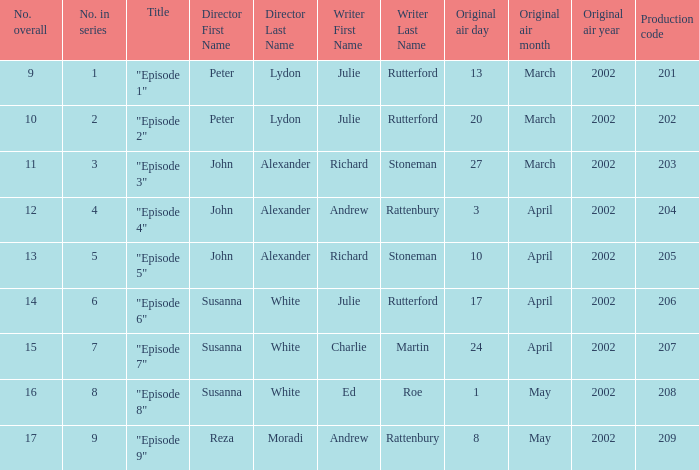Can you parse all the data within this table? {'header': ['No. overall', 'No. in series', 'Title', 'Director First Name', 'Director Last Name', 'Writer First Name', 'Writer Last Name', 'Original air day', 'Original air month', 'Original air year', 'Production code'], 'rows': [['9', '1', '"Episode 1"', 'Peter', 'Lydon', 'Julie', 'Rutterford', '13', 'March', '2002', '201'], ['10', '2', '"Episode 2"', 'Peter', 'Lydon', 'Julie', 'Rutterford', '20', 'March', '2002', '202'], ['11', '3', '"Episode 3"', 'John', 'Alexander', 'Richard', 'Stoneman', '27', 'March', '2002', '203'], ['12', '4', '"Episode 4"', 'John', 'Alexander', 'Andrew', 'Rattenbury', '3', 'April', '2002', '204'], ['13', '5', '"Episode 5"', 'John', 'Alexander', 'Richard', 'Stoneman', '10', 'April', '2002', '205'], ['14', '6', '"Episode 6"', 'Susanna', 'White', 'Julie', 'Rutterford', '17', 'April', '2002', '206'], ['15', '7', '"Episode 7"', 'Susanna', 'White', 'Charlie', 'Martin', '24', 'April', '2002', '207'], ['16', '8', '"Episode 8"', 'Susanna', 'White', 'Ed', 'Roe', '1', 'May', '2002', '208'], ['17', '9', '"Episode 9"', 'Reza', 'Moradi', 'Andrew', 'Rattenbury', '8', 'May', '2002', '209']]} Who holds the director position when the sequence features 1? Peter Lydon. 